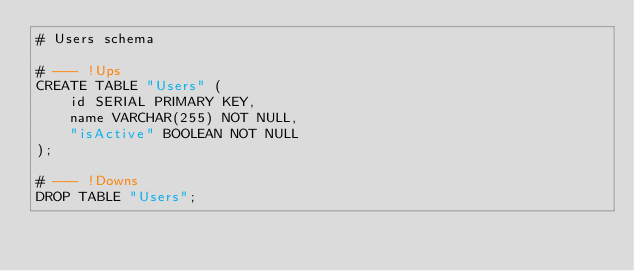Convert code to text. <code><loc_0><loc_0><loc_500><loc_500><_SQL_># Users schema

# --- !Ups
CREATE TABLE "Users" (
    id SERIAL PRIMARY KEY,
    name VARCHAR(255) NOT NULL,
    "isActive" BOOLEAN NOT NULL
);

# --- !Downs
DROP TABLE "Users";</code> 